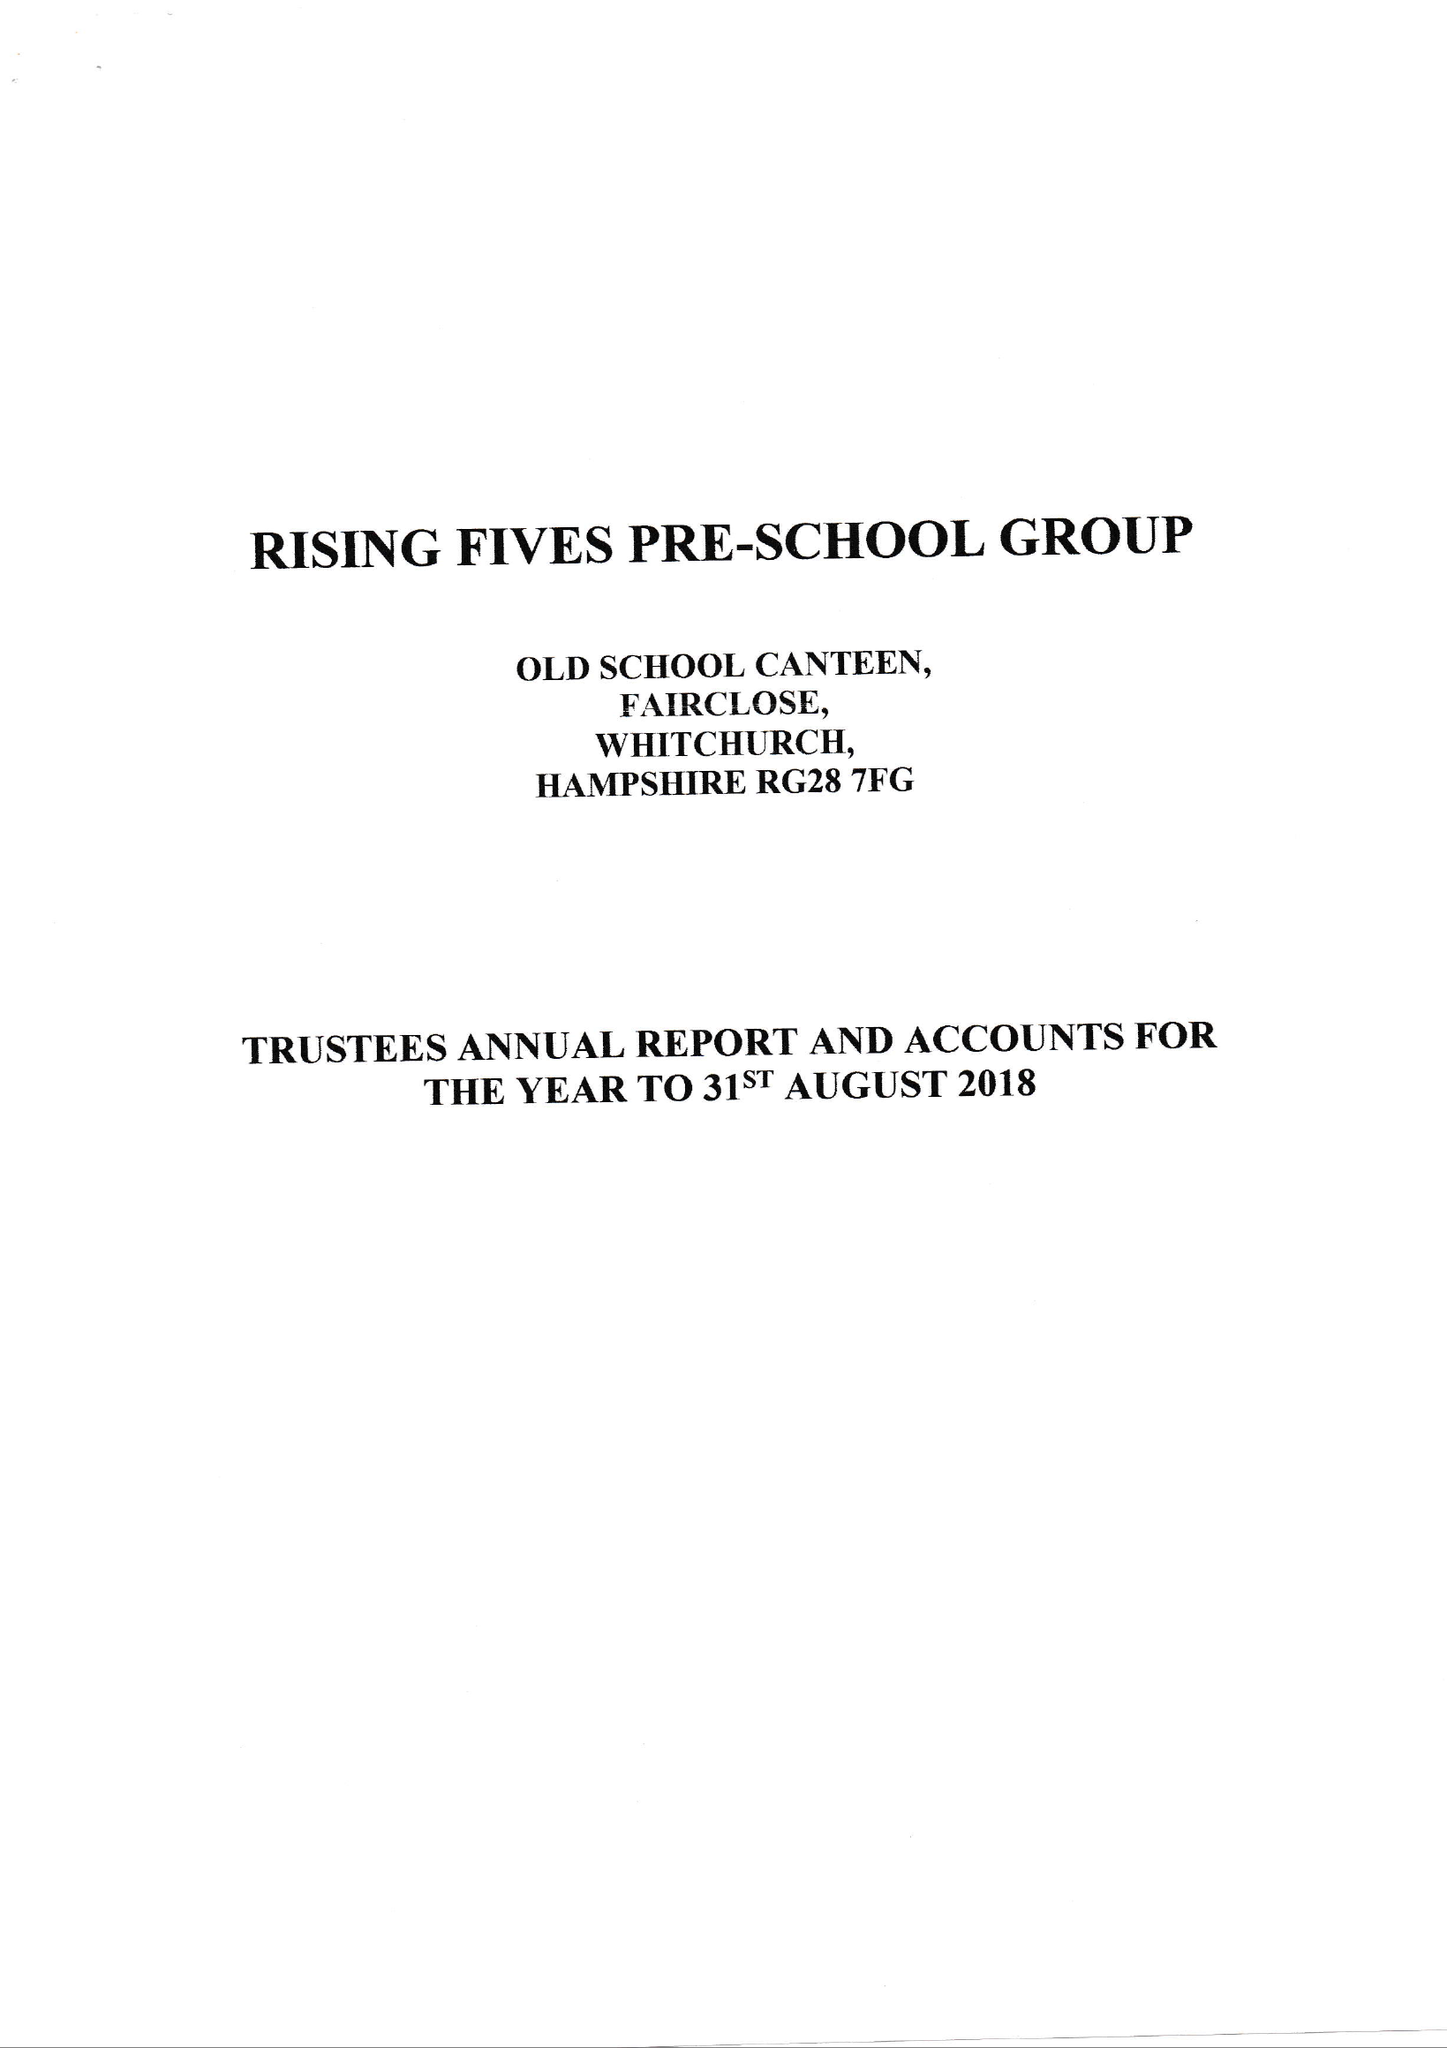What is the value for the address__post_town?
Answer the question using a single word or phrase. WHITCHURCH 